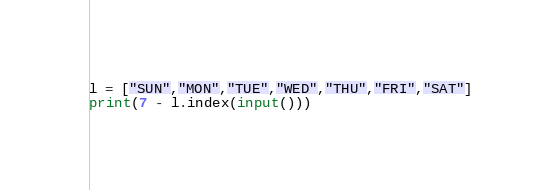Convert code to text. <code><loc_0><loc_0><loc_500><loc_500><_Python_>l = ["SUN","MON","TUE","WED","THU","FRI","SAT"]
print(7 - l.index(input()))</code> 